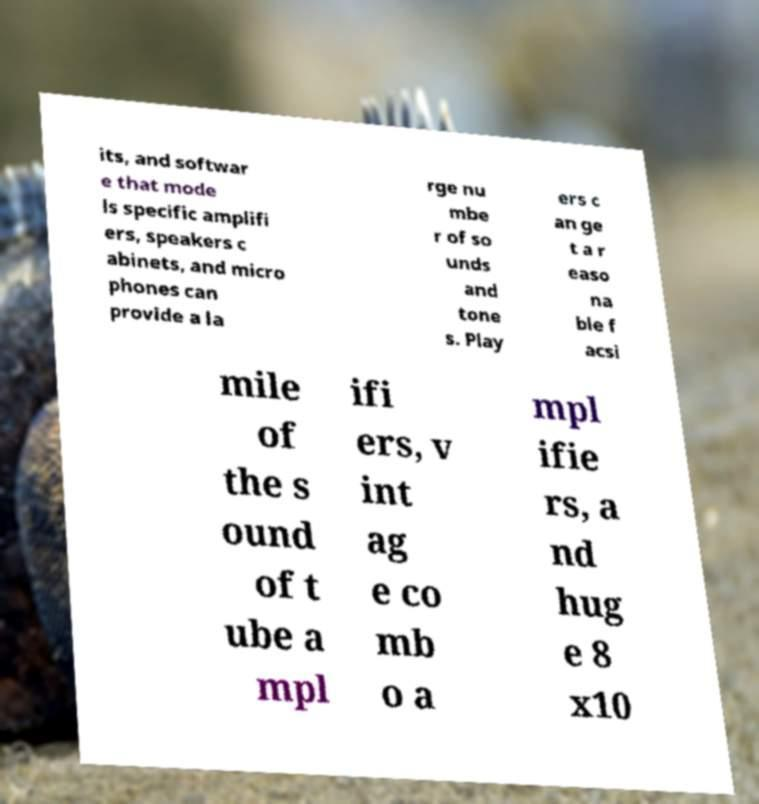What messages or text are displayed in this image? I need them in a readable, typed format. its, and softwar e that mode ls specific amplifi ers, speakers c abinets, and micro phones can provide a la rge nu mbe r of so unds and tone s. Play ers c an ge t a r easo na ble f acsi mile of the s ound of t ube a mpl ifi ers, v int ag e co mb o a mpl ifie rs, a nd hug e 8 x10 